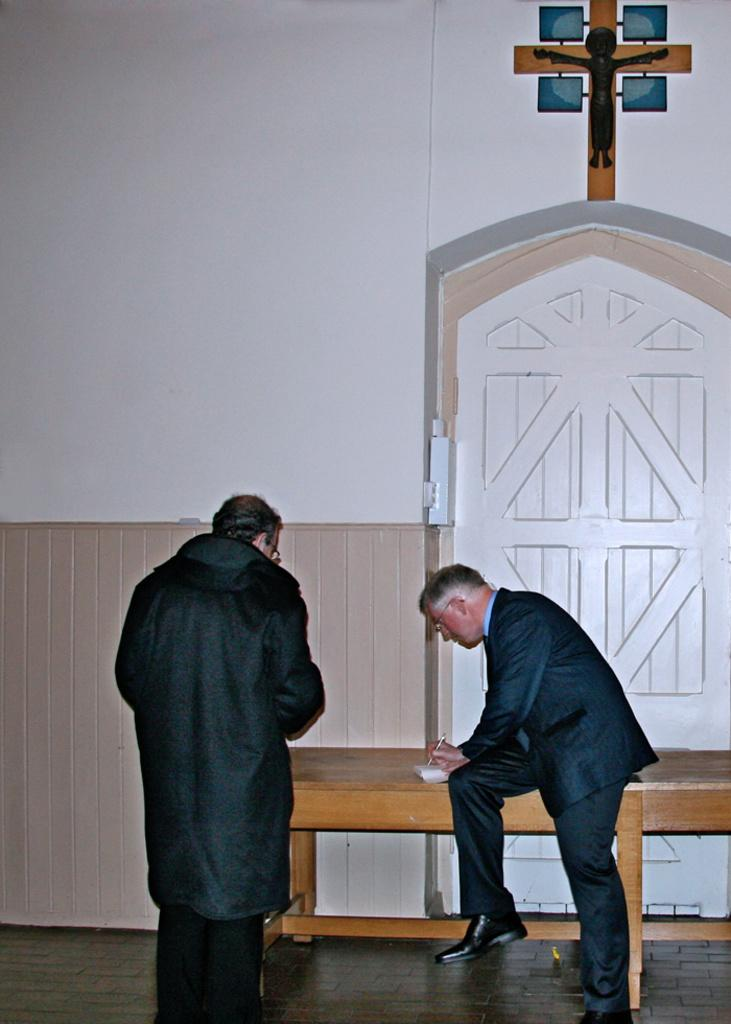How many people are in the image? There are two men in the image. What is the position of one of the men? One man is standing. What is the position of the other man? The other man is seated on a table. What is the seated man doing? The seated man is writing on a paper. What type of care is the man providing to the plant in the image? There is no plant present in the image, so it is not possible to determine if any care is being provided. 